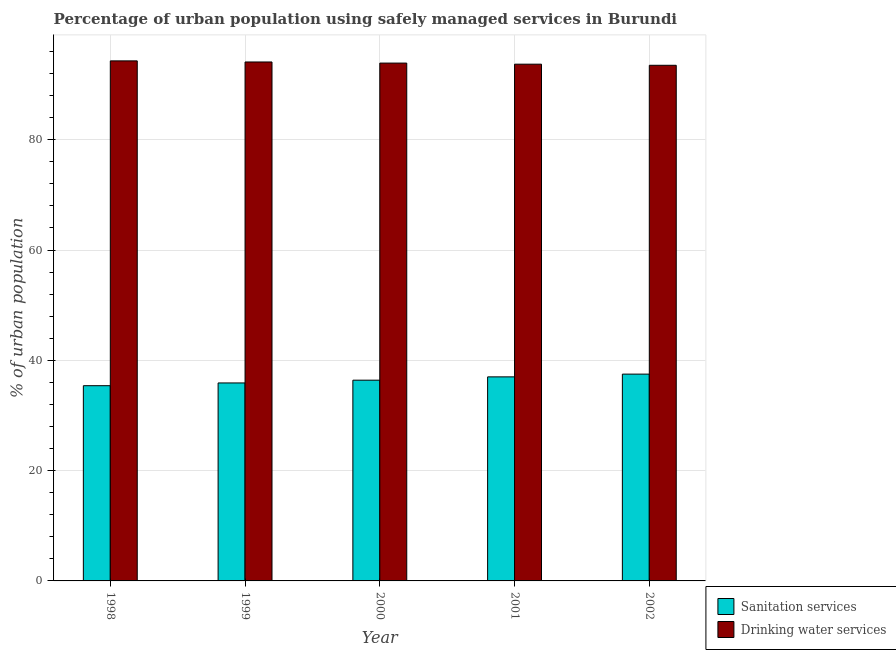Are the number of bars per tick equal to the number of legend labels?
Keep it short and to the point. Yes. How many bars are there on the 4th tick from the right?
Keep it short and to the point. 2. What is the percentage of urban population who used sanitation services in 1998?
Give a very brief answer. 35.4. Across all years, what is the maximum percentage of urban population who used drinking water services?
Ensure brevity in your answer.  94.3. Across all years, what is the minimum percentage of urban population who used sanitation services?
Keep it short and to the point. 35.4. In which year was the percentage of urban population who used sanitation services maximum?
Ensure brevity in your answer.  2002. In which year was the percentage of urban population who used drinking water services minimum?
Your response must be concise. 2002. What is the total percentage of urban population who used sanitation services in the graph?
Keep it short and to the point. 182.2. What is the difference between the percentage of urban population who used drinking water services in 1998 and that in 2000?
Ensure brevity in your answer.  0.4. What is the difference between the percentage of urban population who used sanitation services in 1998 and the percentage of urban population who used drinking water services in 1999?
Your response must be concise. -0.5. What is the average percentage of urban population who used drinking water services per year?
Provide a short and direct response. 93.9. In the year 2000, what is the difference between the percentage of urban population who used drinking water services and percentage of urban population who used sanitation services?
Offer a very short reply. 0. What is the ratio of the percentage of urban population who used sanitation services in 2000 to that in 2001?
Provide a short and direct response. 0.98. What is the difference between the highest and the lowest percentage of urban population who used sanitation services?
Provide a short and direct response. 2.1. What does the 1st bar from the left in 1998 represents?
Your response must be concise. Sanitation services. What does the 2nd bar from the right in 2000 represents?
Provide a short and direct response. Sanitation services. How many bars are there?
Keep it short and to the point. 10. Are all the bars in the graph horizontal?
Offer a terse response. No. What is the difference between two consecutive major ticks on the Y-axis?
Provide a succinct answer. 20. Where does the legend appear in the graph?
Provide a short and direct response. Bottom right. How many legend labels are there?
Provide a short and direct response. 2. What is the title of the graph?
Offer a very short reply. Percentage of urban population using safely managed services in Burundi. What is the label or title of the X-axis?
Your response must be concise. Year. What is the label or title of the Y-axis?
Your answer should be very brief. % of urban population. What is the % of urban population in Sanitation services in 1998?
Your answer should be very brief. 35.4. What is the % of urban population in Drinking water services in 1998?
Give a very brief answer. 94.3. What is the % of urban population of Sanitation services in 1999?
Offer a very short reply. 35.9. What is the % of urban population in Drinking water services in 1999?
Your response must be concise. 94.1. What is the % of urban population in Sanitation services in 2000?
Give a very brief answer. 36.4. What is the % of urban population of Drinking water services in 2000?
Make the answer very short. 93.9. What is the % of urban population of Drinking water services in 2001?
Ensure brevity in your answer.  93.7. What is the % of urban population of Sanitation services in 2002?
Your response must be concise. 37.5. What is the % of urban population in Drinking water services in 2002?
Offer a terse response. 93.5. Across all years, what is the maximum % of urban population in Sanitation services?
Your answer should be very brief. 37.5. Across all years, what is the maximum % of urban population in Drinking water services?
Provide a succinct answer. 94.3. Across all years, what is the minimum % of urban population in Sanitation services?
Your response must be concise. 35.4. Across all years, what is the minimum % of urban population of Drinking water services?
Give a very brief answer. 93.5. What is the total % of urban population in Sanitation services in the graph?
Your answer should be compact. 182.2. What is the total % of urban population of Drinking water services in the graph?
Keep it short and to the point. 469.5. What is the difference between the % of urban population of Sanitation services in 1998 and that in 1999?
Provide a succinct answer. -0.5. What is the difference between the % of urban population of Sanitation services in 1998 and that in 2000?
Provide a succinct answer. -1. What is the difference between the % of urban population in Drinking water services in 1998 and that in 2001?
Ensure brevity in your answer.  0.6. What is the difference between the % of urban population of Sanitation services in 1998 and that in 2002?
Make the answer very short. -2.1. What is the difference between the % of urban population in Drinking water services in 1999 and that in 2000?
Provide a short and direct response. 0.2. What is the difference between the % of urban population in Sanitation services in 1999 and that in 2001?
Keep it short and to the point. -1.1. What is the difference between the % of urban population of Sanitation services in 1999 and that in 2002?
Ensure brevity in your answer.  -1.6. What is the difference between the % of urban population of Drinking water services in 2000 and that in 2002?
Provide a short and direct response. 0.4. What is the difference between the % of urban population in Sanitation services in 2001 and that in 2002?
Your answer should be compact. -0.5. What is the difference between the % of urban population of Drinking water services in 2001 and that in 2002?
Make the answer very short. 0.2. What is the difference between the % of urban population in Sanitation services in 1998 and the % of urban population in Drinking water services in 1999?
Your response must be concise. -58.7. What is the difference between the % of urban population in Sanitation services in 1998 and the % of urban population in Drinking water services in 2000?
Your response must be concise. -58.5. What is the difference between the % of urban population in Sanitation services in 1998 and the % of urban population in Drinking water services in 2001?
Keep it short and to the point. -58.3. What is the difference between the % of urban population of Sanitation services in 1998 and the % of urban population of Drinking water services in 2002?
Make the answer very short. -58.1. What is the difference between the % of urban population of Sanitation services in 1999 and the % of urban population of Drinking water services in 2000?
Ensure brevity in your answer.  -58. What is the difference between the % of urban population of Sanitation services in 1999 and the % of urban population of Drinking water services in 2001?
Make the answer very short. -57.8. What is the difference between the % of urban population of Sanitation services in 1999 and the % of urban population of Drinking water services in 2002?
Ensure brevity in your answer.  -57.6. What is the difference between the % of urban population in Sanitation services in 2000 and the % of urban population in Drinking water services in 2001?
Offer a terse response. -57.3. What is the difference between the % of urban population in Sanitation services in 2000 and the % of urban population in Drinking water services in 2002?
Provide a succinct answer. -57.1. What is the difference between the % of urban population in Sanitation services in 2001 and the % of urban population in Drinking water services in 2002?
Provide a short and direct response. -56.5. What is the average % of urban population in Sanitation services per year?
Provide a succinct answer. 36.44. What is the average % of urban population in Drinking water services per year?
Ensure brevity in your answer.  93.9. In the year 1998, what is the difference between the % of urban population in Sanitation services and % of urban population in Drinking water services?
Your response must be concise. -58.9. In the year 1999, what is the difference between the % of urban population in Sanitation services and % of urban population in Drinking water services?
Ensure brevity in your answer.  -58.2. In the year 2000, what is the difference between the % of urban population in Sanitation services and % of urban population in Drinking water services?
Make the answer very short. -57.5. In the year 2001, what is the difference between the % of urban population in Sanitation services and % of urban population in Drinking water services?
Provide a short and direct response. -56.7. In the year 2002, what is the difference between the % of urban population of Sanitation services and % of urban population of Drinking water services?
Ensure brevity in your answer.  -56. What is the ratio of the % of urban population in Sanitation services in 1998 to that in 1999?
Give a very brief answer. 0.99. What is the ratio of the % of urban population of Drinking water services in 1998 to that in 1999?
Provide a succinct answer. 1. What is the ratio of the % of urban population of Sanitation services in 1998 to that in 2000?
Your response must be concise. 0.97. What is the ratio of the % of urban population in Sanitation services in 1998 to that in 2001?
Keep it short and to the point. 0.96. What is the ratio of the % of urban population of Drinking water services in 1998 to that in 2001?
Make the answer very short. 1.01. What is the ratio of the % of urban population of Sanitation services in 1998 to that in 2002?
Provide a short and direct response. 0.94. What is the ratio of the % of urban population in Drinking water services in 1998 to that in 2002?
Offer a terse response. 1.01. What is the ratio of the % of urban population of Sanitation services in 1999 to that in 2000?
Make the answer very short. 0.99. What is the ratio of the % of urban population of Drinking water services in 1999 to that in 2000?
Give a very brief answer. 1. What is the ratio of the % of urban population in Sanitation services in 1999 to that in 2001?
Your answer should be very brief. 0.97. What is the ratio of the % of urban population of Sanitation services in 1999 to that in 2002?
Make the answer very short. 0.96. What is the ratio of the % of urban population of Drinking water services in 1999 to that in 2002?
Your answer should be very brief. 1.01. What is the ratio of the % of urban population in Sanitation services in 2000 to that in 2001?
Provide a succinct answer. 0.98. What is the ratio of the % of urban population in Sanitation services in 2000 to that in 2002?
Make the answer very short. 0.97. What is the ratio of the % of urban population of Drinking water services in 2000 to that in 2002?
Provide a succinct answer. 1. What is the ratio of the % of urban population in Sanitation services in 2001 to that in 2002?
Make the answer very short. 0.99. What is the difference between the highest and the second highest % of urban population of Sanitation services?
Provide a succinct answer. 0.5. What is the difference between the highest and the second highest % of urban population of Drinking water services?
Offer a very short reply. 0.2. What is the difference between the highest and the lowest % of urban population in Sanitation services?
Offer a very short reply. 2.1. 